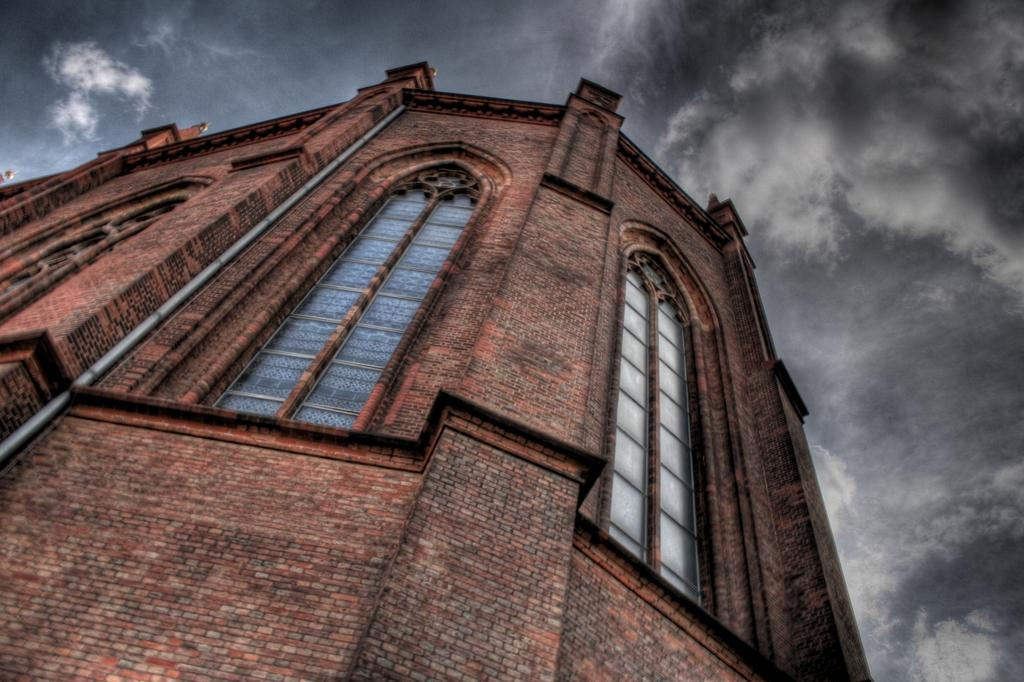What is the main structure in the center of the image? There is a building in the center of the image. What features can be observed on the building? The building has windows and glass elements. What other objects can be seen in the image? There is a pipe and a wall in the image. What is visible in the sky at the top of the image? Clouds are present in the sky at the top of the image. Can you tell me how many robins are perched on the building in the image? There are no robins present in the image; it only features a building, a pipe, a wall, and clouds in the sky. What type of stone is used to construct the building in the image? The image does not provide information about the type of stone used to construct the building, as it only focuses on the presence of windows, glass elements, a pipe, a wall, and clouds in the sky. 